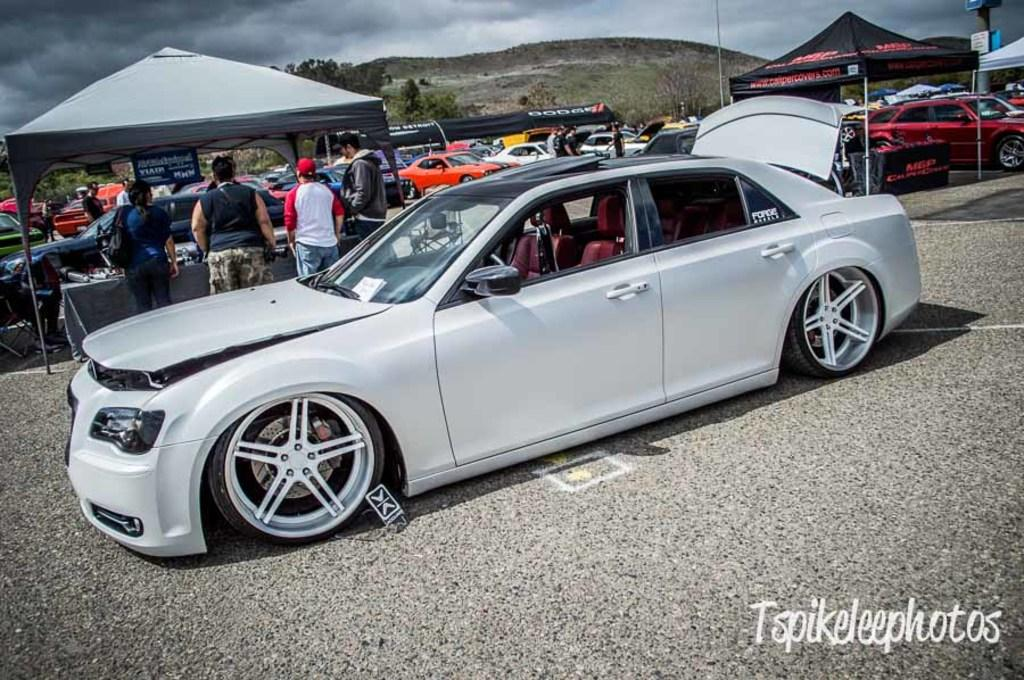What color is the car that is visible on the road in the image? The car on the road is white. What can be seen in the background of the image? In the background, there are people, cars, tents, and trees. What is written in the right bottom corner of the image? There is something written in the right bottom corner of the image. What is the name of the person who was born in the image? There is no person being born in the image, so it is not possible to determine a name. 